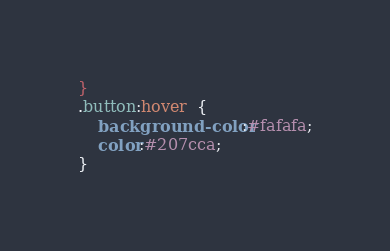Convert code to text. <code><loc_0><loc_0><loc_500><loc_500><_CSS_>}
.button:hover  {
    background-color:#fafafa;
    color:#207cca;
}</code> 